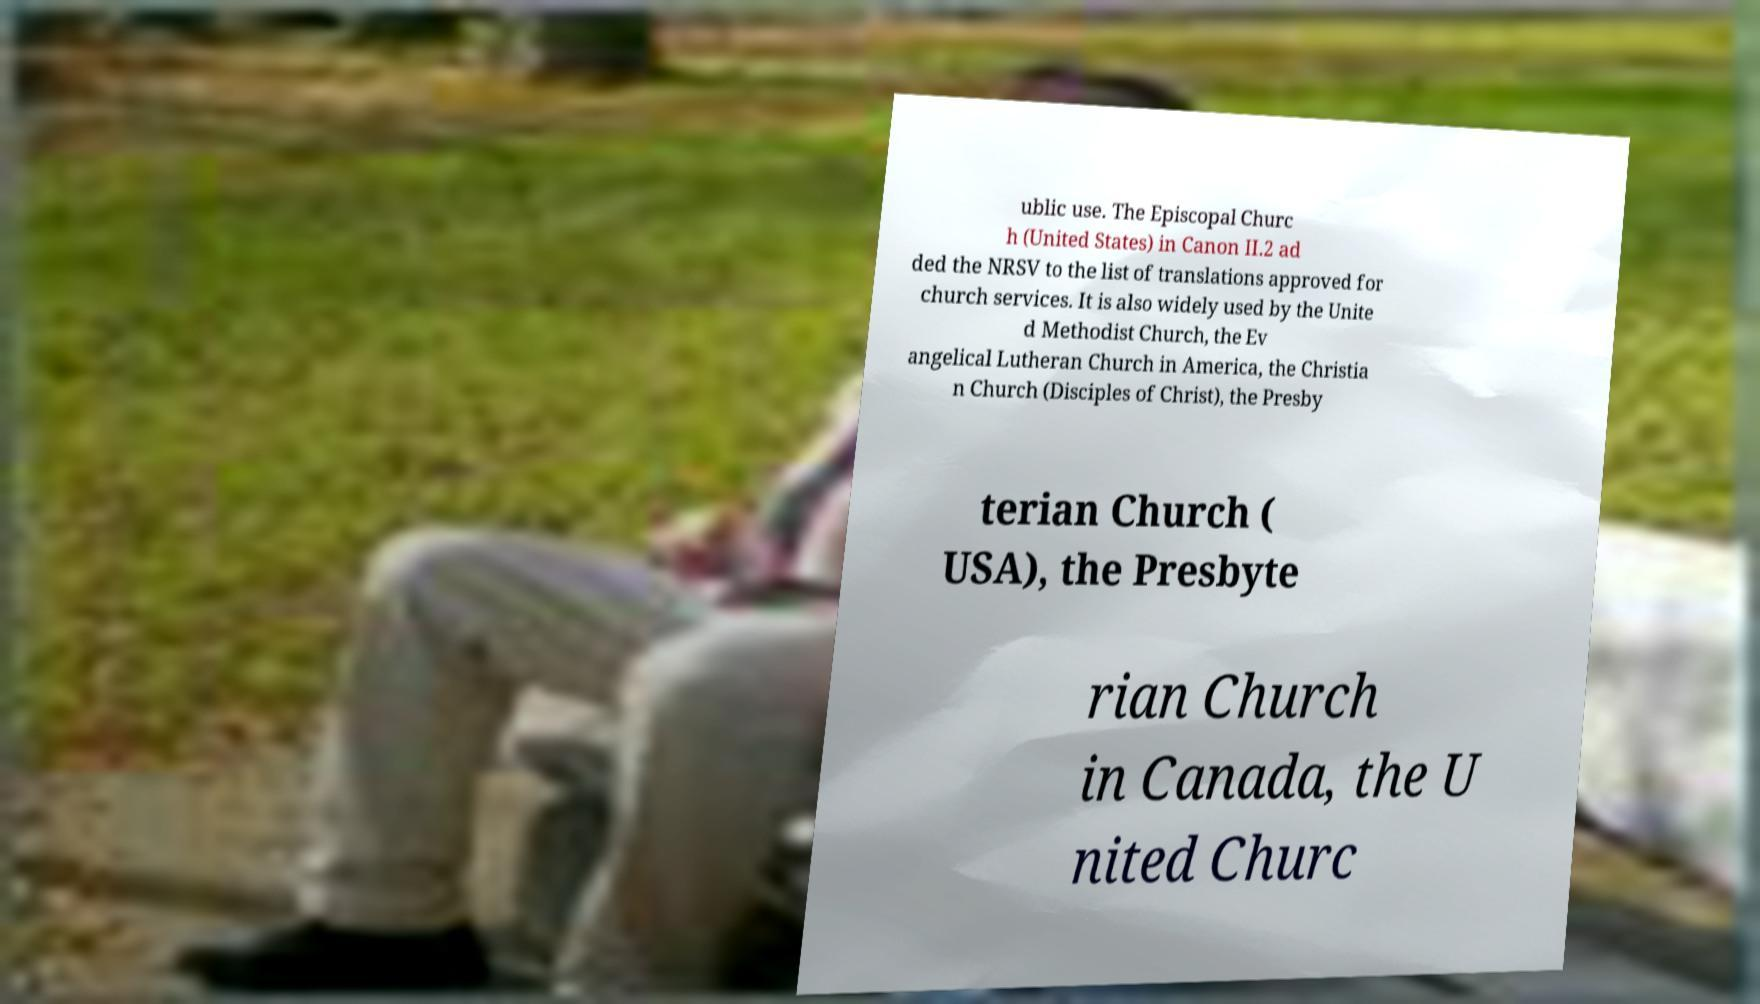Can you accurately transcribe the text from the provided image for me? ublic use. The Episcopal Churc h (United States) in Canon II.2 ad ded the NRSV to the list of translations approved for church services. It is also widely used by the Unite d Methodist Church, the Ev angelical Lutheran Church in America, the Christia n Church (Disciples of Christ), the Presby terian Church ( USA), the Presbyte rian Church in Canada, the U nited Churc 